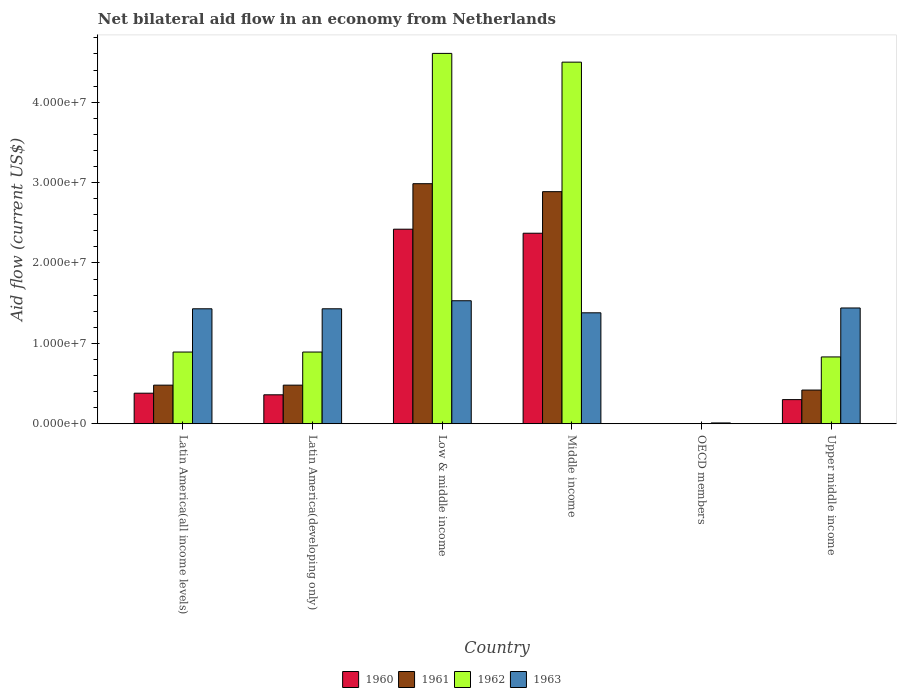How many different coloured bars are there?
Your answer should be very brief. 4. Are the number of bars on each tick of the X-axis equal?
Provide a short and direct response. No. How many bars are there on the 4th tick from the right?
Offer a terse response. 4. What is the label of the 4th group of bars from the left?
Offer a very short reply. Middle income. Across all countries, what is the maximum net bilateral aid flow in 1961?
Provide a succinct answer. 2.99e+07. What is the total net bilateral aid flow in 1960 in the graph?
Your answer should be very brief. 5.83e+07. What is the difference between the net bilateral aid flow in 1960 in Latin America(developing only) and that in Upper middle income?
Offer a terse response. 6.00e+05. What is the difference between the net bilateral aid flow in 1963 in Upper middle income and the net bilateral aid flow in 1961 in Latin America(all income levels)?
Ensure brevity in your answer.  9.60e+06. What is the average net bilateral aid flow in 1963 per country?
Your answer should be very brief. 1.20e+07. What is the difference between the net bilateral aid flow of/in 1961 and net bilateral aid flow of/in 1963 in Upper middle income?
Make the answer very short. -1.02e+07. What is the ratio of the net bilateral aid flow in 1960 in Middle income to that in Upper middle income?
Offer a very short reply. 7.9. Is the net bilateral aid flow in 1961 in Low & middle income less than that in Middle income?
Offer a terse response. No. What is the difference between the highest and the second highest net bilateral aid flow in 1962?
Give a very brief answer. 1.09e+06. What is the difference between the highest and the lowest net bilateral aid flow in 1960?
Provide a short and direct response. 2.42e+07. In how many countries, is the net bilateral aid flow in 1962 greater than the average net bilateral aid flow in 1962 taken over all countries?
Your answer should be compact. 2. Is the sum of the net bilateral aid flow in 1962 in Middle income and Upper middle income greater than the maximum net bilateral aid flow in 1960 across all countries?
Make the answer very short. Yes. Are all the bars in the graph horizontal?
Provide a short and direct response. No. Are the values on the major ticks of Y-axis written in scientific E-notation?
Your response must be concise. Yes. Does the graph contain grids?
Ensure brevity in your answer.  No. How many legend labels are there?
Ensure brevity in your answer.  4. What is the title of the graph?
Offer a very short reply. Net bilateral aid flow in an economy from Netherlands. Does "1975" appear as one of the legend labels in the graph?
Give a very brief answer. No. What is the Aid flow (current US$) in 1960 in Latin America(all income levels)?
Offer a very short reply. 3.80e+06. What is the Aid flow (current US$) of 1961 in Latin America(all income levels)?
Your answer should be compact. 4.80e+06. What is the Aid flow (current US$) of 1962 in Latin America(all income levels)?
Offer a terse response. 8.92e+06. What is the Aid flow (current US$) in 1963 in Latin America(all income levels)?
Your answer should be very brief. 1.43e+07. What is the Aid flow (current US$) of 1960 in Latin America(developing only)?
Give a very brief answer. 3.60e+06. What is the Aid flow (current US$) of 1961 in Latin America(developing only)?
Keep it short and to the point. 4.80e+06. What is the Aid flow (current US$) of 1962 in Latin America(developing only)?
Give a very brief answer. 8.92e+06. What is the Aid flow (current US$) in 1963 in Latin America(developing only)?
Make the answer very short. 1.43e+07. What is the Aid flow (current US$) in 1960 in Low & middle income?
Provide a succinct answer. 2.42e+07. What is the Aid flow (current US$) in 1961 in Low & middle income?
Your response must be concise. 2.99e+07. What is the Aid flow (current US$) in 1962 in Low & middle income?
Your response must be concise. 4.61e+07. What is the Aid flow (current US$) of 1963 in Low & middle income?
Give a very brief answer. 1.53e+07. What is the Aid flow (current US$) in 1960 in Middle income?
Your response must be concise. 2.37e+07. What is the Aid flow (current US$) in 1961 in Middle income?
Provide a succinct answer. 2.89e+07. What is the Aid flow (current US$) of 1962 in Middle income?
Keep it short and to the point. 4.50e+07. What is the Aid flow (current US$) in 1963 in Middle income?
Provide a succinct answer. 1.38e+07. What is the Aid flow (current US$) in 1961 in OECD members?
Your response must be concise. 0. What is the Aid flow (current US$) of 1963 in OECD members?
Provide a short and direct response. 1.00e+05. What is the Aid flow (current US$) of 1961 in Upper middle income?
Make the answer very short. 4.19e+06. What is the Aid flow (current US$) in 1962 in Upper middle income?
Offer a terse response. 8.31e+06. What is the Aid flow (current US$) in 1963 in Upper middle income?
Your response must be concise. 1.44e+07. Across all countries, what is the maximum Aid flow (current US$) of 1960?
Give a very brief answer. 2.42e+07. Across all countries, what is the maximum Aid flow (current US$) of 1961?
Provide a succinct answer. 2.99e+07. Across all countries, what is the maximum Aid flow (current US$) of 1962?
Your answer should be very brief. 4.61e+07. Across all countries, what is the maximum Aid flow (current US$) in 1963?
Your response must be concise. 1.53e+07. Across all countries, what is the minimum Aid flow (current US$) of 1960?
Make the answer very short. 0. Across all countries, what is the minimum Aid flow (current US$) in 1961?
Ensure brevity in your answer.  0. What is the total Aid flow (current US$) of 1960 in the graph?
Ensure brevity in your answer.  5.83e+07. What is the total Aid flow (current US$) of 1961 in the graph?
Keep it short and to the point. 7.25e+07. What is the total Aid flow (current US$) of 1962 in the graph?
Make the answer very short. 1.17e+08. What is the total Aid flow (current US$) of 1963 in the graph?
Provide a succinct answer. 7.22e+07. What is the difference between the Aid flow (current US$) in 1962 in Latin America(all income levels) and that in Latin America(developing only)?
Give a very brief answer. 0. What is the difference between the Aid flow (current US$) in 1960 in Latin America(all income levels) and that in Low & middle income?
Your answer should be very brief. -2.04e+07. What is the difference between the Aid flow (current US$) in 1961 in Latin America(all income levels) and that in Low & middle income?
Offer a very short reply. -2.51e+07. What is the difference between the Aid flow (current US$) in 1962 in Latin America(all income levels) and that in Low & middle income?
Your answer should be very brief. -3.72e+07. What is the difference between the Aid flow (current US$) in 1960 in Latin America(all income levels) and that in Middle income?
Keep it short and to the point. -1.99e+07. What is the difference between the Aid flow (current US$) of 1961 in Latin America(all income levels) and that in Middle income?
Make the answer very short. -2.41e+07. What is the difference between the Aid flow (current US$) of 1962 in Latin America(all income levels) and that in Middle income?
Your response must be concise. -3.61e+07. What is the difference between the Aid flow (current US$) of 1963 in Latin America(all income levels) and that in OECD members?
Your response must be concise. 1.42e+07. What is the difference between the Aid flow (current US$) in 1961 in Latin America(all income levels) and that in Upper middle income?
Provide a succinct answer. 6.10e+05. What is the difference between the Aid flow (current US$) in 1962 in Latin America(all income levels) and that in Upper middle income?
Make the answer very short. 6.10e+05. What is the difference between the Aid flow (current US$) of 1963 in Latin America(all income levels) and that in Upper middle income?
Ensure brevity in your answer.  -1.00e+05. What is the difference between the Aid flow (current US$) in 1960 in Latin America(developing only) and that in Low & middle income?
Your answer should be very brief. -2.06e+07. What is the difference between the Aid flow (current US$) in 1961 in Latin America(developing only) and that in Low & middle income?
Keep it short and to the point. -2.51e+07. What is the difference between the Aid flow (current US$) in 1962 in Latin America(developing only) and that in Low & middle income?
Provide a short and direct response. -3.72e+07. What is the difference between the Aid flow (current US$) of 1960 in Latin America(developing only) and that in Middle income?
Offer a very short reply. -2.01e+07. What is the difference between the Aid flow (current US$) in 1961 in Latin America(developing only) and that in Middle income?
Offer a terse response. -2.41e+07. What is the difference between the Aid flow (current US$) of 1962 in Latin America(developing only) and that in Middle income?
Your answer should be compact. -3.61e+07. What is the difference between the Aid flow (current US$) in 1963 in Latin America(developing only) and that in OECD members?
Your response must be concise. 1.42e+07. What is the difference between the Aid flow (current US$) of 1961 in Latin America(developing only) and that in Upper middle income?
Provide a short and direct response. 6.10e+05. What is the difference between the Aid flow (current US$) in 1963 in Latin America(developing only) and that in Upper middle income?
Ensure brevity in your answer.  -1.00e+05. What is the difference between the Aid flow (current US$) of 1961 in Low & middle income and that in Middle income?
Give a very brief answer. 9.90e+05. What is the difference between the Aid flow (current US$) of 1962 in Low & middle income and that in Middle income?
Offer a very short reply. 1.09e+06. What is the difference between the Aid flow (current US$) of 1963 in Low & middle income and that in Middle income?
Ensure brevity in your answer.  1.50e+06. What is the difference between the Aid flow (current US$) of 1963 in Low & middle income and that in OECD members?
Ensure brevity in your answer.  1.52e+07. What is the difference between the Aid flow (current US$) in 1960 in Low & middle income and that in Upper middle income?
Give a very brief answer. 2.12e+07. What is the difference between the Aid flow (current US$) of 1961 in Low & middle income and that in Upper middle income?
Offer a very short reply. 2.57e+07. What is the difference between the Aid flow (current US$) in 1962 in Low & middle income and that in Upper middle income?
Keep it short and to the point. 3.78e+07. What is the difference between the Aid flow (current US$) in 1963 in Middle income and that in OECD members?
Ensure brevity in your answer.  1.37e+07. What is the difference between the Aid flow (current US$) of 1960 in Middle income and that in Upper middle income?
Keep it short and to the point. 2.07e+07. What is the difference between the Aid flow (current US$) of 1961 in Middle income and that in Upper middle income?
Keep it short and to the point. 2.47e+07. What is the difference between the Aid flow (current US$) of 1962 in Middle income and that in Upper middle income?
Make the answer very short. 3.67e+07. What is the difference between the Aid flow (current US$) of 1963 in Middle income and that in Upper middle income?
Your response must be concise. -6.00e+05. What is the difference between the Aid flow (current US$) of 1963 in OECD members and that in Upper middle income?
Keep it short and to the point. -1.43e+07. What is the difference between the Aid flow (current US$) in 1960 in Latin America(all income levels) and the Aid flow (current US$) in 1962 in Latin America(developing only)?
Make the answer very short. -5.12e+06. What is the difference between the Aid flow (current US$) in 1960 in Latin America(all income levels) and the Aid flow (current US$) in 1963 in Latin America(developing only)?
Offer a very short reply. -1.05e+07. What is the difference between the Aid flow (current US$) of 1961 in Latin America(all income levels) and the Aid flow (current US$) of 1962 in Latin America(developing only)?
Ensure brevity in your answer.  -4.12e+06. What is the difference between the Aid flow (current US$) in 1961 in Latin America(all income levels) and the Aid flow (current US$) in 1963 in Latin America(developing only)?
Offer a very short reply. -9.50e+06. What is the difference between the Aid flow (current US$) of 1962 in Latin America(all income levels) and the Aid flow (current US$) of 1963 in Latin America(developing only)?
Ensure brevity in your answer.  -5.38e+06. What is the difference between the Aid flow (current US$) in 1960 in Latin America(all income levels) and the Aid flow (current US$) in 1961 in Low & middle income?
Give a very brief answer. -2.61e+07. What is the difference between the Aid flow (current US$) in 1960 in Latin America(all income levels) and the Aid flow (current US$) in 1962 in Low & middle income?
Provide a succinct answer. -4.23e+07. What is the difference between the Aid flow (current US$) of 1960 in Latin America(all income levels) and the Aid flow (current US$) of 1963 in Low & middle income?
Provide a succinct answer. -1.15e+07. What is the difference between the Aid flow (current US$) in 1961 in Latin America(all income levels) and the Aid flow (current US$) in 1962 in Low & middle income?
Make the answer very short. -4.13e+07. What is the difference between the Aid flow (current US$) in 1961 in Latin America(all income levels) and the Aid flow (current US$) in 1963 in Low & middle income?
Give a very brief answer. -1.05e+07. What is the difference between the Aid flow (current US$) in 1962 in Latin America(all income levels) and the Aid flow (current US$) in 1963 in Low & middle income?
Give a very brief answer. -6.38e+06. What is the difference between the Aid flow (current US$) of 1960 in Latin America(all income levels) and the Aid flow (current US$) of 1961 in Middle income?
Provide a succinct answer. -2.51e+07. What is the difference between the Aid flow (current US$) in 1960 in Latin America(all income levels) and the Aid flow (current US$) in 1962 in Middle income?
Keep it short and to the point. -4.12e+07. What is the difference between the Aid flow (current US$) of 1960 in Latin America(all income levels) and the Aid flow (current US$) of 1963 in Middle income?
Your answer should be very brief. -1.00e+07. What is the difference between the Aid flow (current US$) in 1961 in Latin America(all income levels) and the Aid flow (current US$) in 1962 in Middle income?
Keep it short and to the point. -4.02e+07. What is the difference between the Aid flow (current US$) of 1961 in Latin America(all income levels) and the Aid flow (current US$) of 1963 in Middle income?
Offer a terse response. -9.00e+06. What is the difference between the Aid flow (current US$) of 1962 in Latin America(all income levels) and the Aid flow (current US$) of 1963 in Middle income?
Make the answer very short. -4.88e+06. What is the difference between the Aid flow (current US$) in 1960 in Latin America(all income levels) and the Aid flow (current US$) in 1963 in OECD members?
Your answer should be compact. 3.70e+06. What is the difference between the Aid flow (current US$) in 1961 in Latin America(all income levels) and the Aid flow (current US$) in 1963 in OECD members?
Provide a short and direct response. 4.70e+06. What is the difference between the Aid flow (current US$) of 1962 in Latin America(all income levels) and the Aid flow (current US$) of 1963 in OECD members?
Give a very brief answer. 8.82e+06. What is the difference between the Aid flow (current US$) in 1960 in Latin America(all income levels) and the Aid flow (current US$) in 1961 in Upper middle income?
Keep it short and to the point. -3.90e+05. What is the difference between the Aid flow (current US$) of 1960 in Latin America(all income levels) and the Aid flow (current US$) of 1962 in Upper middle income?
Offer a very short reply. -4.51e+06. What is the difference between the Aid flow (current US$) of 1960 in Latin America(all income levels) and the Aid flow (current US$) of 1963 in Upper middle income?
Offer a very short reply. -1.06e+07. What is the difference between the Aid flow (current US$) in 1961 in Latin America(all income levels) and the Aid flow (current US$) in 1962 in Upper middle income?
Offer a terse response. -3.51e+06. What is the difference between the Aid flow (current US$) of 1961 in Latin America(all income levels) and the Aid flow (current US$) of 1963 in Upper middle income?
Your response must be concise. -9.60e+06. What is the difference between the Aid flow (current US$) in 1962 in Latin America(all income levels) and the Aid flow (current US$) in 1963 in Upper middle income?
Offer a terse response. -5.48e+06. What is the difference between the Aid flow (current US$) in 1960 in Latin America(developing only) and the Aid flow (current US$) in 1961 in Low & middle income?
Offer a terse response. -2.63e+07. What is the difference between the Aid flow (current US$) of 1960 in Latin America(developing only) and the Aid flow (current US$) of 1962 in Low & middle income?
Provide a short and direct response. -4.25e+07. What is the difference between the Aid flow (current US$) in 1960 in Latin America(developing only) and the Aid flow (current US$) in 1963 in Low & middle income?
Your response must be concise. -1.17e+07. What is the difference between the Aid flow (current US$) in 1961 in Latin America(developing only) and the Aid flow (current US$) in 1962 in Low & middle income?
Keep it short and to the point. -4.13e+07. What is the difference between the Aid flow (current US$) in 1961 in Latin America(developing only) and the Aid flow (current US$) in 1963 in Low & middle income?
Provide a short and direct response. -1.05e+07. What is the difference between the Aid flow (current US$) of 1962 in Latin America(developing only) and the Aid flow (current US$) of 1963 in Low & middle income?
Ensure brevity in your answer.  -6.38e+06. What is the difference between the Aid flow (current US$) of 1960 in Latin America(developing only) and the Aid flow (current US$) of 1961 in Middle income?
Offer a terse response. -2.53e+07. What is the difference between the Aid flow (current US$) of 1960 in Latin America(developing only) and the Aid flow (current US$) of 1962 in Middle income?
Offer a very short reply. -4.14e+07. What is the difference between the Aid flow (current US$) in 1960 in Latin America(developing only) and the Aid flow (current US$) in 1963 in Middle income?
Provide a succinct answer. -1.02e+07. What is the difference between the Aid flow (current US$) in 1961 in Latin America(developing only) and the Aid flow (current US$) in 1962 in Middle income?
Keep it short and to the point. -4.02e+07. What is the difference between the Aid flow (current US$) in 1961 in Latin America(developing only) and the Aid flow (current US$) in 1963 in Middle income?
Your answer should be compact. -9.00e+06. What is the difference between the Aid flow (current US$) in 1962 in Latin America(developing only) and the Aid flow (current US$) in 1963 in Middle income?
Make the answer very short. -4.88e+06. What is the difference between the Aid flow (current US$) in 1960 in Latin America(developing only) and the Aid flow (current US$) in 1963 in OECD members?
Provide a succinct answer. 3.50e+06. What is the difference between the Aid flow (current US$) in 1961 in Latin America(developing only) and the Aid flow (current US$) in 1963 in OECD members?
Keep it short and to the point. 4.70e+06. What is the difference between the Aid flow (current US$) of 1962 in Latin America(developing only) and the Aid flow (current US$) of 1963 in OECD members?
Your answer should be very brief. 8.82e+06. What is the difference between the Aid flow (current US$) in 1960 in Latin America(developing only) and the Aid flow (current US$) in 1961 in Upper middle income?
Your response must be concise. -5.90e+05. What is the difference between the Aid flow (current US$) in 1960 in Latin America(developing only) and the Aid flow (current US$) in 1962 in Upper middle income?
Your answer should be very brief. -4.71e+06. What is the difference between the Aid flow (current US$) in 1960 in Latin America(developing only) and the Aid flow (current US$) in 1963 in Upper middle income?
Provide a short and direct response. -1.08e+07. What is the difference between the Aid flow (current US$) in 1961 in Latin America(developing only) and the Aid flow (current US$) in 1962 in Upper middle income?
Offer a terse response. -3.51e+06. What is the difference between the Aid flow (current US$) in 1961 in Latin America(developing only) and the Aid flow (current US$) in 1963 in Upper middle income?
Offer a very short reply. -9.60e+06. What is the difference between the Aid flow (current US$) of 1962 in Latin America(developing only) and the Aid flow (current US$) of 1963 in Upper middle income?
Your answer should be very brief. -5.48e+06. What is the difference between the Aid flow (current US$) in 1960 in Low & middle income and the Aid flow (current US$) in 1961 in Middle income?
Your response must be concise. -4.67e+06. What is the difference between the Aid flow (current US$) of 1960 in Low & middle income and the Aid flow (current US$) of 1962 in Middle income?
Your response must be concise. -2.08e+07. What is the difference between the Aid flow (current US$) in 1960 in Low & middle income and the Aid flow (current US$) in 1963 in Middle income?
Your answer should be compact. 1.04e+07. What is the difference between the Aid flow (current US$) of 1961 in Low & middle income and the Aid flow (current US$) of 1962 in Middle income?
Ensure brevity in your answer.  -1.51e+07. What is the difference between the Aid flow (current US$) in 1961 in Low & middle income and the Aid flow (current US$) in 1963 in Middle income?
Offer a very short reply. 1.61e+07. What is the difference between the Aid flow (current US$) of 1962 in Low & middle income and the Aid flow (current US$) of 1963 in Middle income?
Offer a very short reply. 3.23e+07. What is the difference between the Aid flow (current US$) in 1960 in Low & middle income and the Aid flow (current US$) in 1963 in OECD members?
Offer a terse response. 2.41e+07. What is the difference between the Aid flow (current US$) of 1961 in Low & middle income and the Aid flow (current US$) of 1963 in OECD members?
Provide a short and direct response. 2.98e+07. What is the difference between the Aid flow (current US$) of 1962 in Low & middle income and the Aid flow (current US$) of 1963 in OECD members?
Offer a terse response. 4.60e+07. What is the difference between the Aid flow (current US$) in 1960 in Low & middle income and the Aid flow (current US$) in 1961 in Upper middle income?
Offer a terse response. 2.00e+07. What is the difference between the Aid flow (current US$) in 1960 in Low & middle income and the Aid flow (current US$) in 1962 in Upper middle income?
Offer a very short reply. 1.59e+07. What is the difference between the Aid flow (current US$) in 1960 in Low & middle income and the Aid flow (current US$) in 1963 in Upper middle income?
Keep it short and to the point. 9.80e+06. What is the difference between the Aid flow (current US$) in 1961 in Low & middle income and the Aid flow (current US$) in 1962 in Upper middle income?
Your answer should be very brief. 2.16e+07. What is the difference between the Aid flow (current US$) of 1961 in Low & middle income and the Aid flow (current US$) of 1963 in Upper middle income?
Provide a short and direct response. 1.55e+07. What is the difference between the Aid flow (current US$) of 1962 in Low & middle income and the Aid flow (current US$) of 1963 in Upper middle income?
Offer a very short reply. 3.17e+07. What is the difference between the Aid flow (current US$) of 1960 in Middle income and the Aid flow (current US$) of 1963 in OECD members?
Your answer should be very brief. 2.36e+07. What is the difference between the Aid flow (current US$) in 1961 in Middle income and the Aid flow (current US$) in 1963 in OECD members?
Provide a short and direct response. 2.88e+07. What is the difference between the Aid flow (current US$) of 1962 in Middle income and the Aid flow (current US$) of 1963 in OECD members?
Your response must be concise. 4.49e+07. What is the difference between the Aid flow (current US$) of 1960 in Middle income and the Aid flow (current US$) of 1961 in Upper middle income?
Your answer should be compact. 1.95e+07. What is the difference between the Aid flow (current US$) of 1960 in Middle income and the Aid flow (current US$) of 1962 in Upper middle income?
Keep it short and to the point. 1.54e+07. What is the difference between the Aid flow (current US$) in 1960 in Middle income and the Aid flow (current US$) in 1963 in Upper middle income?
Ensure brevity in your answer.  9.30e+06. What is the difference between the Aid flow (current US$) in 1961 in Middle income and the Aid flow (current US$) in 1962 in Upper middle income?
Your answer should be compact. 2.06e+07. What is the difference between the Aid flow (current US$) in 1961 in Middle income and the Aid flow (current US$) in 1963 in Upper middle income?
Your response must be concise. 1.45e+07. What is the difference between the Aid flow (current US$) in 1962 in Middle income and the Aid flow (current US$) in 1963 in Upper middle income?
Ensure brevity in your answer.  3.06e+07. What is the average Aid flow (current US$) in 1960 per country?
Your response must be concise. 9.72e+06. What is the average Aid flow (current US$) in 1961 per country?
Your answer should be compact. 1.21e+07. What is the average Aid flow (current US$) in 1962 per country?
Offer a very short reply. 1.95e+07. What is the average Aid flow (current US$) in 1963 per country?
Your answer should be very brief. 1.20e+07. What is the difference between the Aid flow (current US$) of 1960 and Aid flow (current US$) of 1962 in Latin America(all income levels)?
Make the answer very short. -5.12e+06. What is the difference between the Aid flow (current US$) in 1960 and Aid flow (current US$) in 1963 in Latin America(all income levels)?
Your response must be concise. -1.05e+07. What is the difference between the Aid flow (current US$) of 1961 and Aid flow (current US$) of 1962 in Latin America(all income levels)?
Your answer should be very brief. -4.12e+06. What is the difference between the Aid flow (current US$) in 1961 and Aid flow (current US$) in 1963 in Latin America(all income levels)?
Provide a succinct answer. -9.50e+06. What is the difference between the Aid flow (current US$) of 1962 and Aid flow (current US$) of 1963 in Latin America(all income levels)?
Give a very brief answer. -5.38e+06. What is the difference between the Aid flow (current US$) in 1960 and Aid flow (current US$) in 1961 in Latin America(developing only)?
Your answer should be very brief. -1.20e+06. What is the difference between the Aid flow (current US$) in 1960 and Aid flow (current US$) in 1962 in Latin America(developing only)?
Your response must be concise. -5.32e+06. What is the difference between the Aid flow (current US$) of 1960 and Aid flow (current US$) of 1963 in Latin America(developing only)?
Your answer should be compact. -1.07e+07. What is the difference between the Aid flow (current US$) in 1961 and Aid flow (current US$) in 1962 in Latin America(developing only)?
Ensure brevity in your answer.  -4.12e+06. What is the difference between the Aid flow (current US$) in 1961 and Aid flow (current US$) in 1963 in Latin America(developing only)?
Your answer should be very brief. -9.50e+06. What is the difference between the Aid flow (current US$) of 1962 and Aid flow (current US$) of 1963 in Latin America(developing only)?
Make the answer very short. -5.38e+06. What is the difference between the Aid flow (current US$) of 1960 and Aid flow (current US$) of 1961 in Low & middle income?
Your response must be concise. -5.66e+06. What is the difference between the Aid flow (current US$) of 1960 and Aid flow (current US$) of 1962 in Low & middle income?
Your response must be concise. -2.19e+07. What is the difference between the Aid flow (current US$) in 1960 and Aid flow (current US$) in 1963 in Low & middle income?
Ensure brevity in your answer.  8.90e+06. What is the difference between the Aid flow (current US$) in 1961 and Aid flow (current US$) in 1962 in Low & middle income?
Ensure brevity in your answer.  -1.62e+07. What is the difference between the Aid flow (current US$) of 1961 and Aid flow (current US$) of 1963 in Low & middle income?
Provide a succinct answer. 1.46e+07. What is the difference between the Aid flow (current US$) in 1962 and Aid flow (current US$) in 1963 in Low & middle income?
Keep it short and to the point. 3.08e+07. What is the difference between the Aid flow (current US$) of 1960 and Aid flow (current US$) of 1961 in Middle income?
Provide a short and direct response. -5.17e+06. What is the difference between the Aid flow (current US$) of 1960 and Aid flow (current US$) of 1962 in Middle income?
Provide a short and direct response. -2.13e+07. What is the difference between the Aid flow (current US$) of 1960 and Aid flow (current US$) of 1963 in Middle income?
Provide a succinct answer. 9.90e+06. What is the difference between the Aid flow (current US$) of 1961 and Aid flow (current US$) of 1962 in Middle income?
Provide a succinct answer. -1.61e+07. What is the difference between the Aid flow (current US$) in 1961 and Aid flow (current US$) in 1963 in Middle income?
Your response must be concise. 1.51e+07. What is the difference between the Aid flow (current US$) in 1962 and Aid flow (current US$) in 1963 in Middle income?
Keep it short and to the point. 3.12e+07. What is the difference between the Aid flow (current US$) of 1960 and Aid flow (current US$) of 1961 in Upper middle income?
Your answer should be compact. -1.19e+06. What is the difference between the Aid flow (current US$) of 1960 and Aid flow (current US$) of 1962 in Upper middle income?
Give a very brief answer. -5.31e+06. What is the difference between the Aid flow (current US$) in 1960 and Aid flow (current US$) in 1963 in Upper middle income?
Ensure brevity in your answer.  -1.14e+07. What is the difference between the Aid flow (current US$) of 1961 and Aid flow (current US$) of 1962 in Upper middle income?
Make the answer very short. -4.12e+06. What is the difference between the Aid flow (current US$) in 1961 and Aid flow (current US$) in 1963 in Upper middle income?
Your answer should be very brief. -1.02e+07. What is the difference between the Aid flow (current US$) in 1962 and Aid flow (current US$) in 1963 in Upper middle income?
Provide a short and direct response. -6.09e+06. What is the ratio of the Aid flow (current US$) of 1960 in Latin America(all income levels) to that in Latin America(developing only)?
Give a very brief answer. 1.06. What is the ratio of the Aid flow (current US$) of 1962 in Latin America(all income levels) to that in Latin America(developing only)?
Your answer should be compact. 1. What is the ratio of the Aid flow (current US$) of 1960 in Latin America(all income levels) to that in Low & middle income?
Make the answer very short. 0.16. What is the ratio of the Aid flow (current US$) in 1961 in Latin America(all income levels) to that in Low & middle income?
Your answer should be compact. 0.16. What is the ratio of the Aid flow (current US$) in 1962 in Latin America(all income levels) to that in Low & middle income?
Provide a succinct answer. 0.19. What is the ratio of the Aid flow (current US$) in 1963 in Latin America(all income levels) to that in Low & middle income?
Your answer should be compact. 0.93. What is the ratio of the Aid flow (current US$) in 1960 in Latin America(all income levels) to that in Middle income?
Your response must be concise. 0.16. What is the ratio of the Aid flow (current US$) in 1961 in Latin America(all income levels) to that in Middle income?
Give a very brief answer. 0.17. What is the ratio of the Aid flow (current US$) in 1962 in Latin America(all income levels) to that in Middle income?
Keep it short and to the point. 0.2. What is the ratio of the Aid flow (current US$) of 1963 in Latin America(all income levels) to that in Middle income?
Your response must be concise. 1.04. What is the ratio of the Aid flow (current US$) of 1963 in Latin America(all income levels) to that in OECD members?
Your answer should be compact. 143. What is the ratio of the Aid flow (current US$) in 1960 in Latin America(all income levels) to that in Upper middle income?
Offer a very short reply. 1.27. What is the ratio of the Aid flow (current US$) in 1961 in Latin America(all income levels) to that in Upper middle income?
Make the answer very short. 1.15. What is the ratio of the Aid flow (current US$) in 1962 in Latin America(all income levels) to that in Upper middle income?
Ensure brevity in your answer.  1.07. What is the ratio of the Aid flow (current US$) in 1960 in Latin America(developing only) to that in Low & middle income?
Your response must be concise. 0.15. What is the ratio of the Aid flow (current US$) in 1961 in Latin America(developing only) to that in Low & middle income?
Provide a short and direct response. 0.16. What is the ratio of the Aid flow (current US$) of 1962 in Latin America(developing only) to that in Low & middle income?
Offer a very short reply. 0.19. What is the ratio of the Aid flow (current US$) of 1963 in Latin America(developing only) to that in Low & middle income?
Ensure brevity in your answer.  0.93. What is the ratio of the Aid flow (current US$) in 1960 in Latin America(developing only) to that in Middle income?
Ensure brevity in your answer.  0.15. What is the ratio of the Aid flow (current US$) in 1961 in Latin America(developing only) to that in Middle income?
Keep it short and to the point. 0.17. What is the ratio of the Aid flow (current US$) in 1962 in Latin America(developing only) to that in Middle income?
Offer a very short reply. 0.2. What is the ratio of the Aid flow (current US$) of 1963 in Latin America(developing only) to that in Middle income?
Give a very brief answer. 1.04. What is the ratio of the Aid flow (current US$) of 1963 in Latin America(developing only) to that in OECD members?
Your answer should be compact. 143. What is the ratio of the Aid flow (current US$) in 1961 in Latin America(developing only) to that in Upper middle income?
Make the answer very short. 1.15. What is the ratio of the Aid flow (current US$) in 1962 in Latin America(developing only) to that in Upper middle income?
Your answer should be compact. 1.07. What is the ratio of the Aid flow (current US$) in 1963 in Latin America(developing only) to that in Upper middle income?
Give a very brief answer. 0.99. What is the ratio of the Aid flow (current US$) of 1960 in Low & middle income to that in Middle income?
Provide a succinct answer. 1.02. What is the ratio of the Aid flow (current US$) of 1961 in Low & middle income to that in Middle income?
Offer a terse response. 1.03. What is the ratio of the Aid flow (current US$) in 1962 in Low & middle income to that in Middle income?
Provide a short and direct response. 1.02. What is the ratio of the Aid flow (current US$) in 1963 in Low & middle income to that in Middle income?
Provide a succinct answer. 1.11. What is the ratio of the Aid flow (current US$) in 1963 in Low & middle income to that in OECD members?
Ensure brevity in your answer.  153. What is the ratio of the Aid flow (current US$) in 1960 in Low & middle income to that in Upper middle income?
Ensure brevity in your answer.  8.07. What is the ratio of the Aid flow (current US$) in 1961 in Low & middle income to that in Upper middle income?
Provide a succinct answer. 7.13. What is the ratio of the Aid flow (current US$) of 1962 in Low & middle income to that in Upper middle income?
Your answer should be compact. 5.54. What is the ratio of the Aid flow (current US$) of 1963 in Middle income to that in OECD members?
Make the answer very short. 138. What is the ratio of the Aid flow (current US$) in 1960 in Middle income to that in Upper middle income?
Ensure brevity in your answer.  7.9. What is the ratio of the Aid flow (current US$) in 1961 in Middle income to that in Upper middle income?
Your response must be concise. 6.89. What is the ratio of the Aid flow (current US$) in 1962 in Middle income to that in Upper middle income?
Offer a terse response. 5.41. What is the ratio of the Aid flow (current US$) in 1963 in Middle income to that in Upper middle income?
Offer a terse response. 0.96. What is the ratio of the Aid flow (current US$) of 1963 in OECD members to that in Upper middle income?
Offer a terse response. 0.01. What is the difference between the highest and the second highest Aid flow (current US$) in 1961?
Ensure brevity in your answer.  9.90e+05. What is the difference between the highest and the second highest Aid flow (current US$) of 1962?
Make the answer very short. 1.09e+06. What is the difference between the highest and the second highest Aid flow (current US$) in 1963?
Keep it short and to the point. 9.00e+05. What is the difference between the highest and the lowest Aid flow (current US$) in 1960?
Offer a very short reply. 2.42e+07. What is the difference between the highest and the lowest Aid flow (current US$) of 1961?
Ensure brevity in your answer.  2.99e+07. What is the difference between the highest and the lowest Aid flow (current US$) of 1962?
Make the answer very short. 4.61e+07. What is the difference between the highest and the lowest Aid flow (current US$) of 1963?
Offer a terse response. 1.52e+07. 